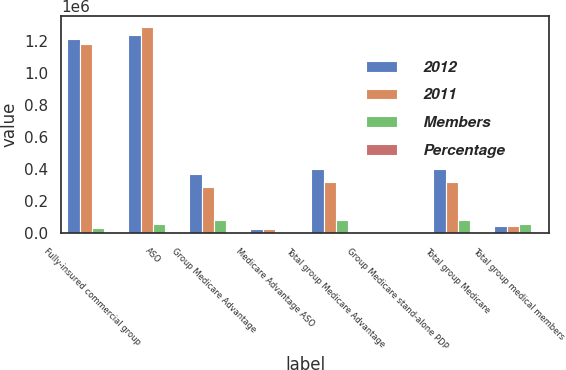Convert chart. <chart><loc_0><loc_0><loc_500><loc_500><stacked_bar_chart><ecel><fcel>Fully-insured commercial group<fcel>ASO<fcel>Group Medicare Advantage<fcel>Medicare Advantage ASO<fcel>Total group Medicare Advantage<fcel>Group Medicare stand-alone PDP<fcel>Total group Medicare<fcel>Total group medical members<nl><fcel>2012<fcel>1.2118e+06<fcel>1.2377e+06<fcel>370800<fcel>27700<fcel>398500<fcel>4400<fcel>402900<fcel>43100<nl><fcel>2011<fcel>1.1802e+06<fcel>1.2923e+06<fcel>290600<fcel>27600<fcel>318200<fcel>4200<fcel>322400<fcel>43100<nl><fcel>Members<fcel>31600<fcel>54600<fcel>80200<fcel>100<fcel>80300<fcel>200<fcel>80500<fcel>57500<nl><fcel>Percentage<fcel>2.7<fcel>4.2<fcel>27.6<fcel>0.4<fcel>25.2<fcel>4.8<fcel>25<fcel>2.1<nl></chart> 